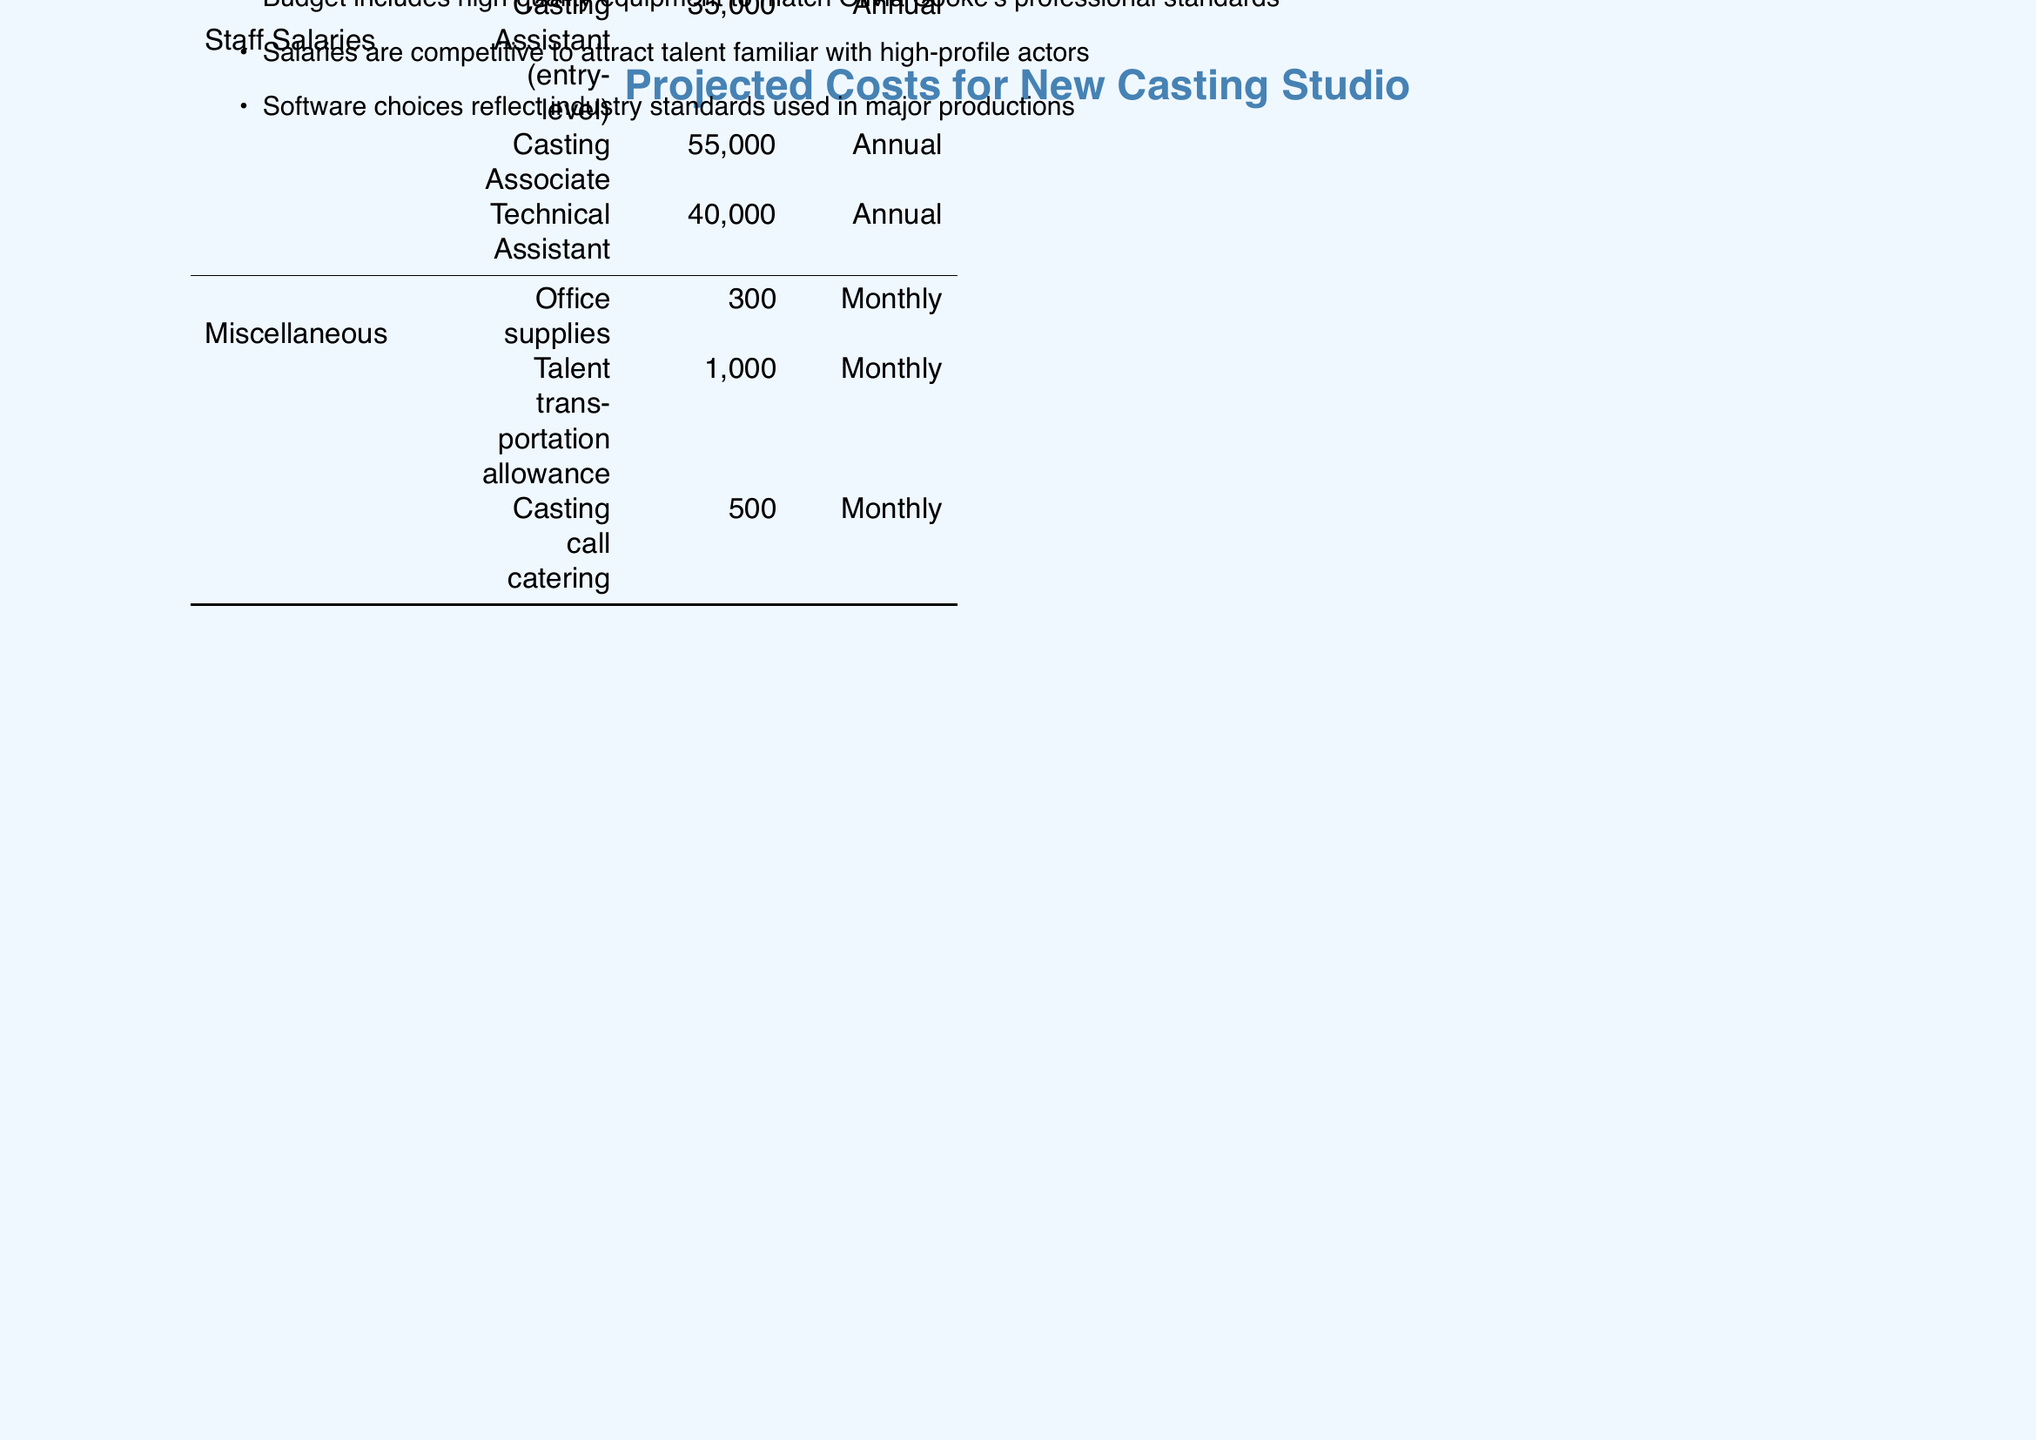what is the monthly cost for studio rental? The monthly cost for studio rental is specified in the document under the Space category, which states it as $4000.
Answer: $4000 what is the total annual cost for staff salaries? The total annual cost for staff salaries is the sum of individual salaries listed in the document for the Casting Assistant, Casting Associate, and Technical Assistant, amounting to $130,000.
Answer: $130,000 how many Sony FX6 Cameras are being purchased? The document indicates that two Sony FX6 Cameras are included in the projected costs under Equipment.
Answer: 2 what is the frequency for the insurance payment? The document lists insurance under the Space category with an annual frequency indicated.
Answer: Annual what is the total one-time cost for equipment? The total one-time cost for equipment is calculated by adding the costs of all equipment listed, resulting in $31,500.
Answer: $31,500 what is the total monthly cost? The total monthly cost is directly stated in the document under the financial summary, totaling $6,690.
Answer: $6,690 what software has an annual cost? The document mentions the Final Draft as a software item with an annual cost.
Answer: Final Draft how much is the talent transportation allowance? The document specifies the talent transportation allowance as a monthly item costing $1,000.
Answer: $1,000 